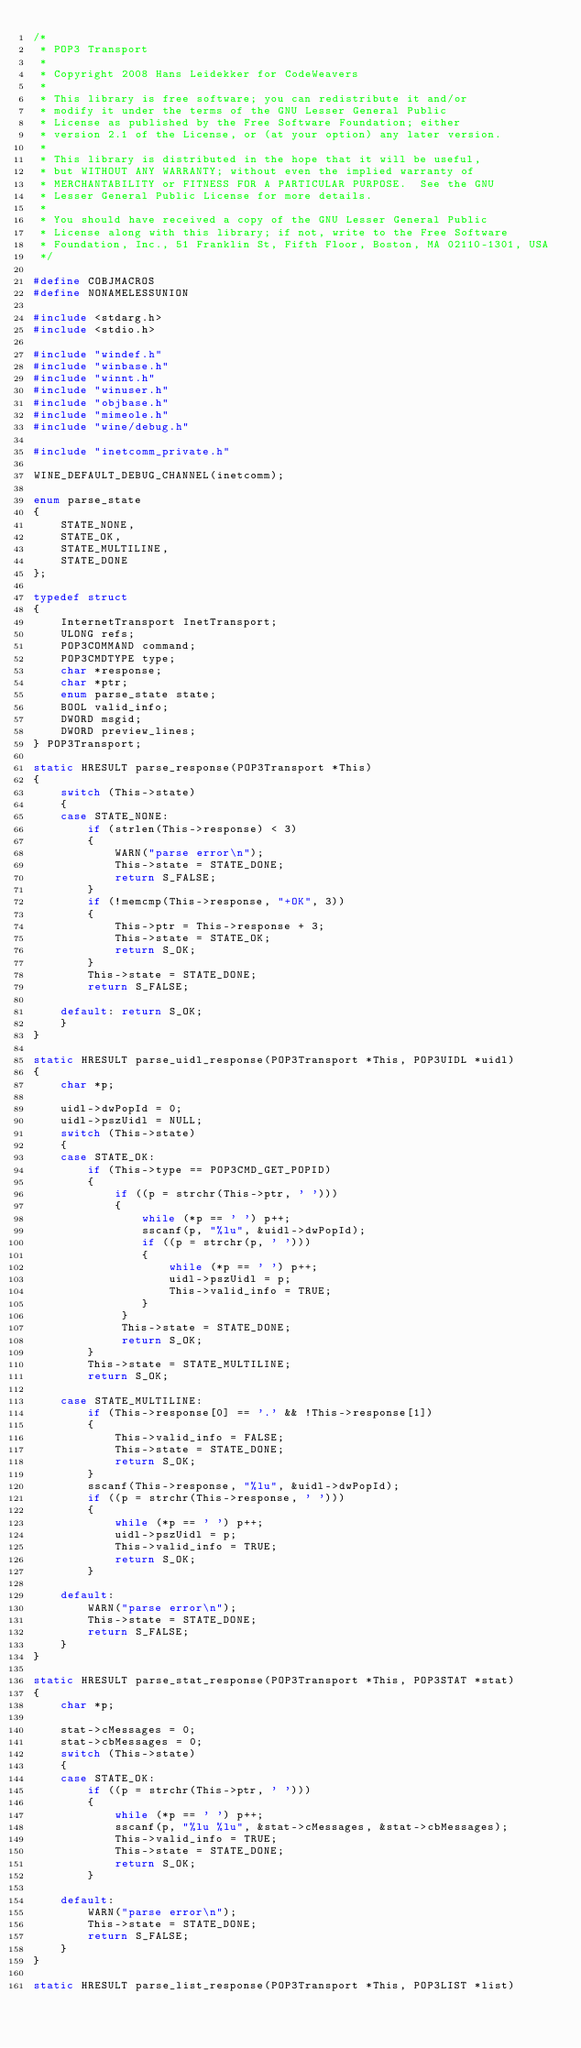Convert code to text. <code><loc_0><loc_0><loc_500><loc_500><_C_>/*
 * POP3 Transport
 *
 * Copyright 2008 Hans Leidekker for CodeWeavers
 *
 * This library is free software; you can redistribute it and/or
 * modify it under the terms of the GNU Lesser General Public
 * License as published by the Free Software Foundation; either
 * version 2.1 of the License, or (at your option) any later version.
 *
 * This library is distributed in the hope that it will be useful,
 * but WITHOUT ANY WARRANTY; without even the implied warranty of
 * MERCHANTABILITY or FITNESS FOR A PARTICULAR PURPOSE.  See the GNU
 * Lesser General Public License for more details.
 *
 * You should have received a copy of the GNU Lesser General Public
 * License along with this library; if not, write to the Free Software
 * Foundation, Inc., 51 Franklin St, Fifth Floor, Boston, MA 02110-1301, USA
 */

#define COBJMACROS
#define NONAMELESSUNION

#include <stdarg.h>
#include <stdio.h>

#include "windef.h"
#include "winbase.h"
#include "winnt.h"
#include "winuser.h"
#include "objbase.h"
#include "mimeole.h"
#include "wine/debug.h"

#include "inetcomm_private.h"

WINE_DEFAULT_DEBUG_CHANNEL(inetcomm);

enum parse_state
{
    STATE_NONE,
    STATE_OK,
    STATE_MULTILINE,
    STATE_DONE
};

typedef struct
{
    InternetTransport InetTransport;
    ULONG refs;
    POP3COMMAND command;
    POP3CMDTYPE type;
    char *response;
    char *ptr;
    enum parse_state state;
    BOOL valid_info;
    DWORD msgid;
    DWORD preview_lines;
} POP3Transport;

static HRESULT parse_response(POP3Transport *This)
{
    switch (This->state)
    {
    case STATE_NONE:
        if (strlen(This->response) < 3)
        {
            WARN("parse error\n");
            This->state = STATE_DONE;
            return S_FALSE;
        }
        if (!memcmp(This->response, "+OK", 3))
        {
            This->ptr = This->response + 3;
            This->state = STATE_OK;
            return S_OK;
        }
        This->state = STATE_DONE;
        return S_FALSE;

    default: return S_OK;
    }
}

static HRESULT parse_uidl_response(POP3Transport *This, POP3UIDL *uidl)
{
    char *p;

    uidl->dwPopId = 0;
    uidl->pszUidl = NULL;
    switch (This->state)
    {
    case STATE_OK:
        if (This->type == POP3CMD_GET_POPID)
        {
            if ((p = strchr(This->ptr, ' ')))
            {
                while (*p == ' ') p++;
                sscanf(p, "%lu", &uidl->dwPopId);
                if ((p = strchr(p, ' ')))
                {
                    while (*p == ' ') p++;
                    uidl->pszUidl = p;
                    This->valid_info = TRUE;
                }
             }
             This->state = STATE_DONE;
             return S_OK;
        }
        This->state = STATE_MULTILINE;
        return S_OK;

    case STATE_MULTILINE:
        if (This->response[0] == '.' && !This->response[1])
        {
            This->valid_info = FALSE;
            This->state = STATE_DONE;
            return S_OK;
        }
        sscanf(This->response, "%lu", &uidl->dwPopId);
        if ((p = strchr(This->response, ' ')))
        {
            while (*p == ' ') p++;
            uidl->pszUidl = p;
            This->valid_info = TRUE;
            return S_OK;
        }

    default:
        WARN("parse error\n");
        This->state = STATE_DONE;
        return S_FALSE;
    }
}

static HRESULT parse_stat_response(POP3Transport *This, POP3STAT *stat)
{
    char *p;

    stat->cMessages = 0;
    stat->cbMessages = 0;
    switch (This->state)
    {
    case STATE_OK:
        if ((p = strchr(This->ptr, ' ')))
        {
            while (*p == ' ') p++;
            sscanf(p, "%lu %lu", &stat->cMessages, &stat->cbMessages);
            This->valid_info = TRUE;
            This->state = STATE_DONE;
            return S_OK;
        }

    default:
        WARN("parse error\n");
        This->state = STATE_DONE;
        return S_FALSE;
    }
}

static HRESULT parse_list_response(POP3Transport *This, POP3LIST *list)</code> 